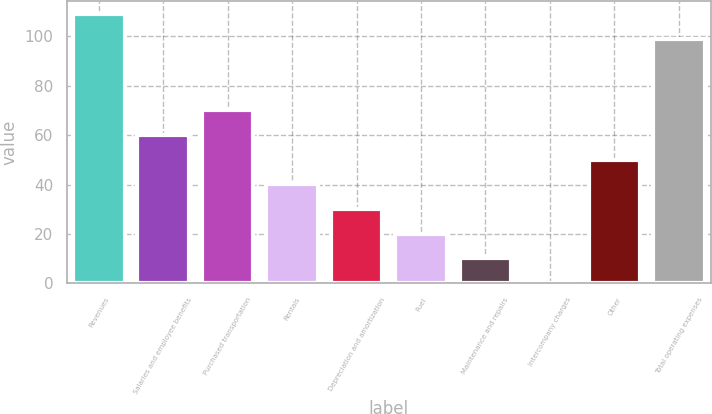Convert chart to OTSL. <chart><loc_0><loc_0><loc_500><loc_500><bar_chart><fcel>Revenues<fcel>Salaries and employee benefits<fcel>Purchased transportation<fcel>Rentals<fcel>Depreciation and amortization<fcel>Fuel<fcel>Maintenance and repairs<fcel>Intercompany charges<fcel>Other<fcel>Total operating expenses<nl><fcel>108.88<fcel>60.08<fcel>70.06<fcel>40.12<fcel>30.14<fcel>20.16<fcel>10.18<fcel>0.2<fcel>50.1<fcel>98.9<nl></chart> 